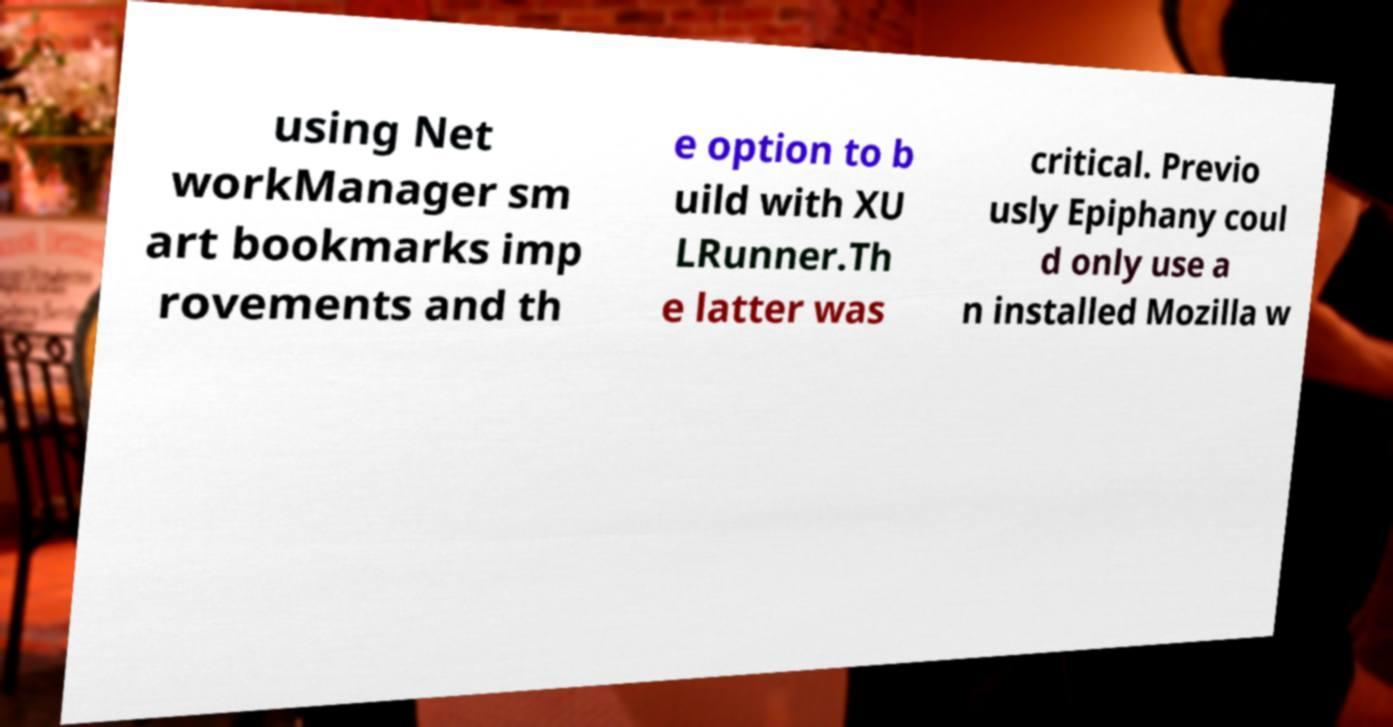Can you accurately transcribe the text from the provided image for me? using Net workManager sm art bookmarks imp rovements and th e option to b uild with XU LRunner.Th e latter was critical. Previo usly Epiphany coul d only use a n installed Mozilla w 